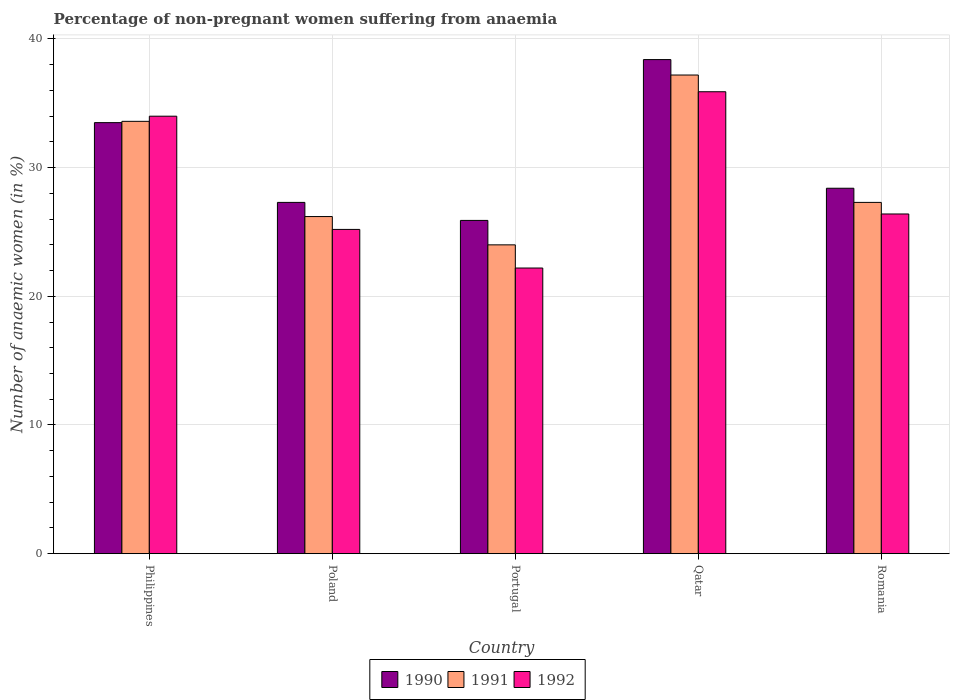How many groups of bars are there?
Provide a succinct answer. 5. Are the number of bars per tick equal to the number of legend labels?
Provide a short and direct response. Yes. Are the number of bars on each tick of the X-axis equal?
Keep it short and to the point. Yes. In how many cases, is the number of bars for a given country not equal to the number of legend labels?
Ensure brevity in your answer.  0. What is the percentage of non-pregnant women suffering from anaemia in 1990 in Portugal?
Offer a very short reply. 25.9. Across all countries, what is the maximum percentage of non-pregnant women suffering from anaemia in 1991?
Offer a very short reply. 37.2. Across all countries, what is the minimum percentage of non-pregnant women suffering from anaemia in 1990?
Your response must be concise. 25.9. In which country was the percentage of non-pregnant women suffering from anaemia in 1991 maximum?
Provide a succinct answer. Qatar. In which country was the percentage of non-pregnant women suffering from anaemia in 1990 minimum?
Provide a short and direct response. Portugal. What is the total percentage of non-pregnant women suffering from anaemia in 1992 in the graph?
Keep it short and to the point. 143.7. What is the difference between the percentage of non-pregnant women suffering from anaemia in 1991 in Qatar and that in Romania?
Make the answer very short. 9.9. What is the difference between the percentage of non-pregnant women suffering from anaemia in 1992 in Philippines and the percentage of non-pregnant women suffering from anaemia in 1991 in Romania?
Make the answer very short. 6.7. What is the average percentage of non-pregnant women suffering from anaemia in 1992 per country?
Ensure brevity in your answer.  28.74. What is the difference between the percentage of non-pregnant women suffering from anaemia of/in 1990 and percentage of non-pregnant women suffering from anaemia of/in 1992 in Qatar?
Ensure brevity in your answer.  2.5. In how many countries, is the percentage of non-pregnant women suffering from anaemia in 1991 greater than 2 %?
Provide a succinct answer. 5. What is the ratio of the percentage of non-pregnant women suffering from anaemia in 1992 in Poland to that in Qatar?
Your answer should be compact. 0.7. Is the percentage of non-pregnant women suffering from anaemia in 1991 in Philippines less than that in Portugal?
Ensure brevity in your answer.  No. Is the difference between the percentage of non-pregnant women suffering from anaemia in 1990 in Philippines and Poland greater than the difference between the percentage of non-pregnant women suffering from anaemia in 1992 in Philippines and Poland?
Provide a succinct answer. No. What is the difference between the highest and the second highest percentage of non-pregnant women suffering from anaemia in 1992?
Your response must be concise. -7.6. What is the difference between the highest and the lowest percentage of non-pregnant women suffering from anaemia in 1992?
Provide a succinct answer. 13.7. Is the sum of the percentage of non-pregnant women suffering from anaemia in 1991 in Poland and Portugal greater than the maximum percentage of non-pregnant women suffering from anaemia in 1990 across all countries?
Provide a succinct answer. Yes. How many bars are there?
Offer a terse response. 15. Are all the bars in the graph horizontal?
Your answer should be very brief. No. How many countries are there in the graph?
Offer a very short reply. 5. What is the difference between two consecutive major ticks on the Y-axis?
Provide a short and direct response. 10. Does the graph contain grids?
Your response must be concise. Yes. How many legend labels are there?
Ensure brevity in your answer.  3. What is the title of the graph?
Offer a terse response. Percentage of non-pregnant women suffering from anaemia. What is the label or title of the Y-axis?
Offer a very short reply. Number of anaemic women (in %). What is the Number of anaemic women (in %) in 1990 in Philippines?
Your response must be concise. 33.5. What is the Number of anaemic women (in %) of 1991 in Philippines?
Offer a terse response. 33.6. What is the Number of anaemic women (in %) of 1990 in Poland?
Offer a terse response. 27.3. What is the Number of anaemic women (in %) in 1991 in Poland?
Offer a very short reply. 26.2. What is the Number of anaemic women (in %) of 1992 in Poland?
Offer a terse response. 25.2. What is the Number of anaemic women (in %) of 1990 in Portugal?
Provide a short and direct response. 25.9. What is the Number of anaemic women (in %) in 1991 in Portugal?
Your answer should be compact. 24. What is the Number of anaemic women (in %) of 1992 in Portugal?
Give a very brief answer. 22.2. What is the Number of anaemic women (in %) in 1990 in Qatar?
Your answer should be compact. 38.4. What is the Number of anaemic women (in %) of 1991 in Qatar?
Your answer should be very brief. 37.2. What is the Number of anaemic women (in %) in 1992 in Qatar?
Provide a succinct answer. 35.9. What is the Number of anaemic women (in %) of 1990 in Romania?
Offer a terse response. 28.4. What is the Number of anaemic women (in %) of 1991 in Romania?
Ensure brevity in your answer.  27.3. What is the Number of anaemic women (in %) of 1992 in Romania?
Ensure brevity in your answer.  26.4. Across all countries, what is the maximum Number of anaemic women (in %) in 1990?
Ensure brevity in your answer.  38.4. Across all countries, what is the maximum Number of anaemic women (in %) of 1991?
Keep it short and to the point. 37.2. Across all countries, what is the maximum Number of anaemic women (in %) of 1992?
Provide a short and direct response. 35.9. Across all countries, what is the minimum Number of anaemic women (in %) in 1990?
Give a very brief answer. 25.9. What is the total Number of anaemic women (in %) in 1990 in the graph?
Provide a succinct answer. 153.5. What is the total Number of anaemic women (in %) in 1991 in the graph?
Ensure brevity in your answer.  148.3. What is the total Number of anaemic women (in %) in 1992 in the graph?
Keep it short and to the point. 143.7. What is the difference between the Number of anaemic women (in %) of 1990 in Philippines and that in Poland?
Your response must be concise. 6.2. What is the difference between the Number of anaemic women (in %) in 1990 in Philippines and that in Portugal?
Offer a terse response. 7.6. What is the difference between the Number of anaemic women (in %) in 1991 in Philippines and that in Portugal?
Give a very brief answer. 9.6. What is the difference between the Number of anaemic women (in %) in 1992 in Philippines and that in Portugal?
Ensure brevity in your answer.  11.8. What is the difference between the Number of anaemic women (in %) in 1990 in Philippines and that in Qatar?
Keep it short and to the point. -4.9. What is the difference between the Number of anaemic women (in %) of 1991 in Philippines and that in Qatar?
Your answer should be very brief. -3.6. What is the difference between the Number of anaemic women (in %) of 1992 in Philippines and that in Qatar?
Your answer should be compact. -1.9. What is the difference between the Number of anaemic women (in %) in 1990 in Philippines and that in Romania?
Your response must be concise. 5.1. What is the difference between the Number of anaemic women (in %) in 1991 in Poland and that in Qatar?
Provide a short and direct response. -11. What is the difference between the Number of anaemic women (in %) of 1992 in Poland and that in Qatar?
Your answer should be very brief. -10.7. What is the difference between the Number of anaemic women (in %) of 1990 in Poland and that in Romania?
Your answer should be very brief. -1.1. What is the difference between the Number of anaemic women (in %) of 1992 in Poland and that in Romania?
Your answer should be compact. -1.2. What is the difference between the Number of anaemic women (in %) of 1990 in Portugal and that in Qatar?
Ensure brevity in your answer.  -12.5. What is the difference between the Number of anaemic women (in %) of 1991 in Portugal and that in Qatar?
Your answer should be very brief. -13.2. What is the difference between the Number of anaemic women (in %) of 1992 in Portugal and that in Qatar?
Your answer should be compact. -13.7. What is the difference between the Number of anaemic women (in %) in 1991 in Portugal and that in Romania?
Your response must be concise. -3.3. What is the difference between the Number of anaemic women (in %) in 1992 in Portugal and that in Romania?
Your answer should be very brief. -4.2. What is the difference between the Number of anaemic women (in %) of 1990 in Qatar and that in Romania?
Your answer should be compact. 10. What is the difference between the Number of anaemic women (in %) of 1991 in Qatar and that in Romania?
Ensure brevity in your answer.  9.9. What is the difference between the Number of anaemic women (in %) in 1992 in Qatar and that in Romania?
Provide a succinct answer. 9.5. What is the difference between the Number of anaemic women (in %) of 1990 in Philippines and the Number of anaemic women (in %) of 1991 in Poland?
Give a very brief answer. 7.3. What is the difference between the Number of anaemic women (in %) in 1990 in Philippines and the Number of anaemic women (in %) in 1992 in Poland?
Keep it short and to the point. 8.3. What is the difference between the Number of anaemic women (in %) of 1990 in Philippines and the Number of anaemic women (in %) of 1991 in Portugal?
Offer a terse response. 9.5. What is the difference between the Number of anaemic women (in %) of 1990 in Philippines and the Number of anaemic women (in %) of 1992 in Portugal?
Offer a very short reply. 11.3. What is the difference between the Number of anaemic women (in %) in 1990 in Philippines and the Number of anaemic women (in %) in 1992 in Qatar?
Ensure brevity in your answer.  -2.4. What is the difference between the Number of anaemic women (in %) of 1991 in Philippines and the Number of anaemic women (in %) of 1992 in Qatar?
Offer a terse response. -2.3. What is the difference between the Number of anaemic women (in %) of 1990 in Philippines and the Number of anaemic women (in %) of 1992 in Romania?
Keep it short and to the point. 7.1. What is the difference between the Number of anaemic women (in %) in 1991 in Philippines and the Number of anaemic women (in %) in 1992 in Romania?
Your response must be concise. 7.2. What is the difference between the Number of anaemic women (in %) in 1990 in Poland and the Number of anaemic women (in %) in 1991 in Portugal?
Offer a very short reply. 3.3. What is the difference between the Number of anaemic women (in %) in 1990 in Poland and the Number of anaemic women (in %) in 1992 in Portugal?
Provide a succinct answer. 5.1. What is the difference between the Number of anaemic women (in %) in 1991 in Poland and the Number of anaemic women (in %) in 1992 in Portugal?
Provide a succinct answer. 4. What is the difference between the Number of anaemic women (in %) in 1991 in Poland and the Number of anaemic women (in %) in 1992 in Qatar?
Your response must be concise. -9.7. What is the difference between the Number of anaemic women (in %) in 1990 in Poland and the Number of anaemic women (in %) in 1991 in Romania?
Give a very brief answer. 0. What is the difference between the Number of anaemic women (in %) in 1990 in Poland and the Number of anaemic women (in %) in 1992 in Romania?
Provide a succinct answer. 0.9. What is the difference between the Number of anaemic women (in %) in 1991 in Poland and the Number of anaemic women (in %) in 1992 in Romania?
Ensure brevity in your answer.  -0.2. What is the difference between the Number of anaemic women (in %) in 1990 in Portugal and the Number of anaemic women (in %) in 1992 in Qatar?
Offer a terse response. -10. What is the difference between the Number of anaemic women (in %) of 1990 in Portugal and the Number of anaemic women (in %) of 1992 in Romania?
Make the answer very short. -0.5. What is the difference between the Number of anaemic women (in %) of 1991 in Portugal and the Number of anaemic women (in %) of 1992 in Romania?
Keep it short and to the point. -2.4. What is the difference between the Number of anaemic women (in %) in 1991 in Qatar and the Number of anaemic women (in %) in 1992 in Romania?
Ensure brevity in your answer.  10.8. What is the average Number of anaemic women (in %) of 1990 per country?
Provide a succinct answer. 30.7. What is the average Number of anaemic women (in %) of 1991 per country?
Offer a very short reply. 29.66. What is the average Number of anaemic women (in %) in 1992 per country?
Ensure brevity in your answer.  28.74. What is the difference between the Number of anaemic women (in %) in 1990 and Number of anaemic women (in %) in 1992 in Portugal?
Offer a terse response. 3.7. What is the difference between the Number of anaemic women (in %) in 1991 and Number of anaemic women (in %) in 1992 in Romania?
Your response must be concise. 0.9. What is the ratio of the Number of anaemic women (in %) in 1990 in Philippines to that in Poland?
Your response must be concise. 1.23. What is the ratio of the Number of anaemic women (in %) in 1991 in Philippines to that in Poland?
Keep it short and to the point. 1.28. What is the ratio of the Number of anaemic women (in %) of 1992 in Philippines to that in Poland?
Your response must be concise. 1.35. What is the ratio of the Number of anaemic women (in %) in 1990 in Philippines to that in Portugal?
Provide a succinct answer. 1.29. What is the ratio of the Number of anaemic women (in %) in 1992 in Philippines to that in Portugal?
Provide a short and direct response. 1.53. What is the ratio of the Number of anaemic women (in %) of 1990 in Philippines to that in Qatar?
Provide a succinct answer. 0.87. What is the ratio of the Number of anaemic women (in %) in 1991 in Philippines to that in Qatar?
Make the answer very short. 0.9. What is the ratio of the Number of anaemic women (in %) of 1992 in Philippines to that in Qatar?
Provide a succinct answer. 0.95. What is the ratio of the Number of anaemic women (in %) of 1990 in Philippines to that in Romania?
Ensure brevity in your answer.  1.18. What is the ratio of the Number of anaemic women (in %) in 1991 in Philippines to that in Romania?
Your answer should be very brief. 1.23. What is the ratio of the Number of anaemic women (in %) of 1992 in Philippines to that in Romania?
Keep it short and to the point. 1.29. What is the ratio of the Number of anaemic women (in %) of 1990 in Poland to that in Portugal?
Your response must be concise. 1.05. What is the ratio of the Number of anaemic women (in %) in 1991 in Poland to that in Portugal?
Provide a succinct answer. 1.09. What is the ratio of the Number of anaemic women (in %) of 1992 in Poland to that in Portugal?
Offer a very short reply. 1.14. What is the ratio of the Number of anaemic women (in %) in 1990 in Poland to that in Qatar?
Your response must be concise. 0.71. What is the ratio of the Number of anaemic women (in %) of 1991 in Poland to that in Qatar?
Provide a short and direct response. 0.7. What is the ratio of the Number of anaemic women (in %) in 1992 in Poland to that in Qatar?
Give a very brief answer. 0.7. What is the ratio of the Number of anaemic women (in %) of 1990 in Poland to that in Romania?
Offer a terse response. 0.96. What is the ratio of the Number of anaemic women (in %) in 1991 in Poland to that in Romania?
Provide a succinct answer. 0.96. What is the ratio of the Number of anaemic women (in %) of 1992 in Poland to that in Romania?
Make the answer very short. 0.95. What is the ratio of the Number of anaemic women (in %) of 1990 in Portugal to that in Qatar?
Ensure brevity in your answer.  0.67. What is the ratio of the Number of anaemic women (in %) in 1991 in Portugal to that in Qatar?
Provide a succinct answer. 0.65. What is the ratio of the Number of anaemic women (in %) of 1992 in Portugal to that in Qatar?
Your response must be concise. 0.62. What is the ratio of the Number of anaemic women (in %) in 1990 in Portugal to that in Romania?
Give a very brief answer. 0.91. What is the ratio of the Number of anaemic women (in %) in 1991 in Portugal to that in Romania?
Offer a very short reply. 0.88. What is the ratio of the Number of anaemic women (in %) in 1992 in Portugal to that in Romania?
Provide a succinct answer. 0.84. What is the ratio of the Number of anaemic women (in %) in 1990 in Qatar to that in Romania?
Offer a terse response. 1.35. What is the ratio of the Number of anaemic women (in %) in 1991 in Qatar to that in Romania?
Provide a short and direct response. 1.36. What is the ratio of the Number of anaemic women (in %) of 1992 in Qatar to that in Romania?
Keep it short and to the point. 1.36. What is the difference between the highest and the second highest Number of anaemic women (in %) in 1990?
Make the answer very short. 4.9. What is the difference between the highest and the second highest Number of anaemic women (in %) in 1991?
Your answer should be very brief. 3.6. What is the difference between the highest and the lowest Number of anaemic women (in %) of 1990?
Offer a terse response. 12.5. 